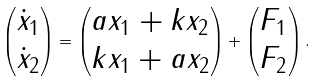Convert formula to latex. <formula><loc_0><loc_0><loc_500><loc_500>\begin{pmatrix} \dot { x } _ { 1 } \\ \dot { x } _ { 2 } \end{pmatrix} = \begin{pmatrix} a x _ { 1 } + k x _ { 2 } \\ k x _ { 1 } + a x _ { 2 } \end{pmatrix} + \begin{pmatrix} F _ { 1 } \\ F _ { 2 } \end{pmatrix} .</formula> 